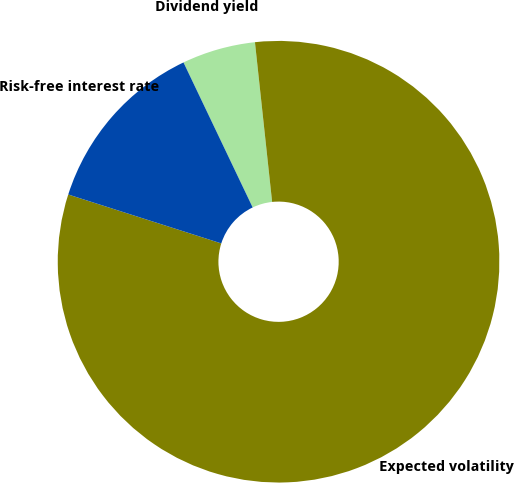Convert chart to OTSL. <chart><loc_0><loc_0><loc_500><loc_500><pie_chart><fcel>Dividend yield<fcel>Expected volatility<fcel>Risk-free interest rate<nl><fcel>5.38%<fcel>81.63%<fcel>12.99%<nl></chart> 